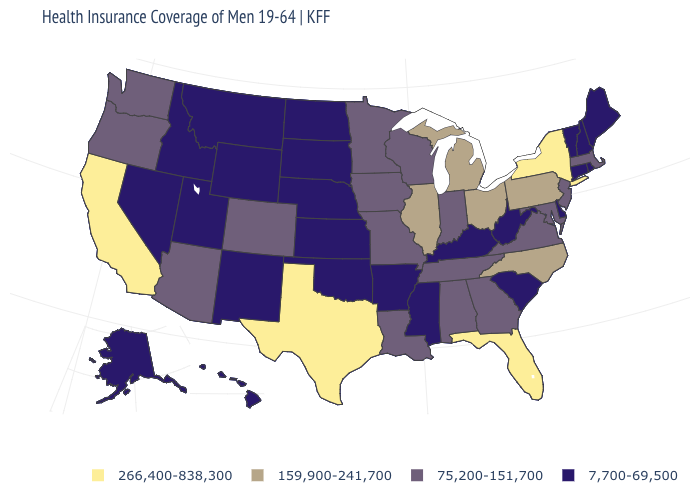Name the states that have a value in the range 7,700-69,500?
Quick response, please. Alaska, Arkansas, Connecticut, Delaware, Hawaii, Idaho, Kansas, Kentucky, Maine, Mississippi, Montana, Nebraska, Nevada, New Hampshire, New Mexico, North Dakota, Oklahoma, Rhode Island, South Carolina, South Dakota, Utah, Vermont, West Virginia, Wyoming. Is the legend a continuous bar?
Answer briefly. No. What is the value of Pennsylvania?
Short answer required. 159,900-241,700. Does Oregon have the lowest value in the USA?
Write a very short answer. No. What is the value of Rhode Island?
Short answer required. 7,700-69,500. What is the lowest value in states that border Georgia?
Give a very brief answer. 7,700-69,500. Among the states that border Massachusetts , which have the highest value?
Answer briefly. New York. Is the legend a continuous bar?
Concise answer only. No. Does Arkansas have the lowest value in the USA?
Be succinct. Yes. What is the highest value in the USA?
Be succinct. 266,400-838,300. What is the value of New Jersey?
Quick response, please. 75,200-151,700. What is the value of North Carolina?
Answer briefly. 159,900-241,700. What is the value of New Jersey?
Write a very short answer. 75,200-151,700. Name the states that have a value in the range 159,900-241,700?
Keep it brief. Illinois, Michigan, North Carolina, Ohio, Pennsylvania. 